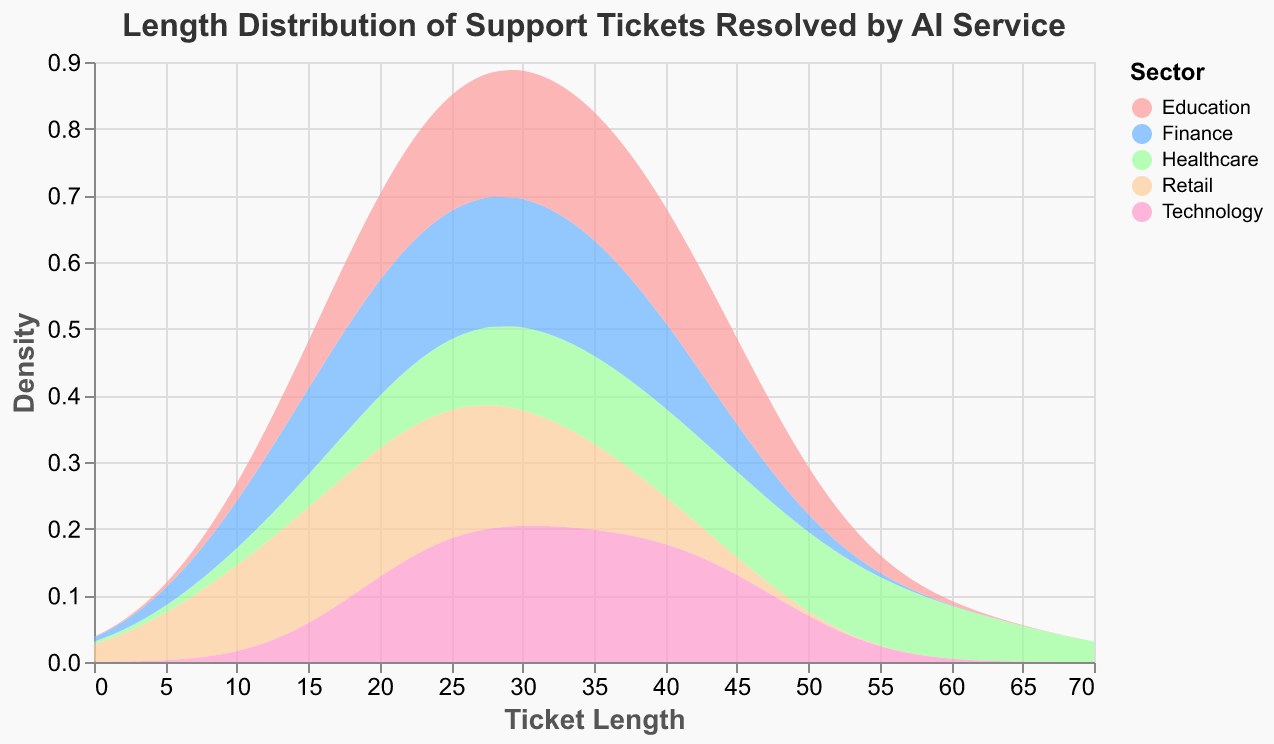what is the title of the figure? The title of the figure is located at the top of the plot and is typically the largest and boldest text in the visual.
Answer: Length Distribution of Support Tickets Resolved by AI Service how many sectors are represented in the plot? The sectors are differentiated by distinct colors in the plot and can be visually counted. There are five colors indicating five sectors listed in the legend.
Answer: 5 which sector has the widest range of ticket lengths? The width of the range can be determined by observing the density curves for each sector. The Healthcare sector has a range extending from approximately 20 to 60, which is the widest range.
Answer: Healthcare what is the general shape of the distribution for the Finance sector? By examining the density curve for the Finance sector, characterized by its blue color, it shows a peak around 25 to 35 and is relatively symmetrical.
Answer: Symmetrical with a peak around 25 to 35 what is the most common ticket length in the Retail sector? The most common ticket length is indicated by the peak of the density curve for the Retail sector. Retail sector, designated by the green curve, peaks around 20 and 25.
Answer: 20 - 25 how do the ticket lengths in the Education sector compare to those in the Technology sector? The density curves for both sectors can be compared directly. Both sectors have ticket lengths primarily in the range of 20 to 45. Education has a unified rise, whereas Technology has a broader rise and fall.
Answer: Education 20-45, Technology 20-45 which sector's support tickets have the least variability in length? The sector with the most narrow and highest peak in its density curve has the least variability. The Finance sector density curve peaks sharply between 20 and 40, indicating low variability.
Answer: Finance what is the average ticket length range for the Healthcare sector? The central interval of the Healthcare sector curve, which displays nearly symmetrical and evenly spread rising and falling from 20 to 60, provides the average range.
Answer: 20 - 60 between Retail and Technology, which sector has the lower average ticket length? By comparing the positions of the density curve peaks, Retail sector peaks around lower lengths (10 to 30), whereas Technology sector peaks around (30).
Answer: Retail what can be inferred about ticket length distributions across sectors? Inference is made by observing all density curves. Each sector shows unique distribution shapes and ranges, indicating different usual ticket lengths resolved by the AI service.
Answer: Varied distributions and ranges across sectors 